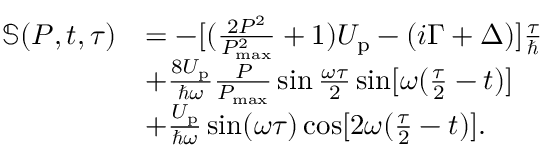<formula> <loc_0><loc_0><loc_500><loc_500>\begin{array} { r l } { \mathbb { S } ( P , t , \tau ) } & { = - [ ( \frac { 2 P ^ { 2 } } { P _ { \max } ^ { 2 } } + 1 ) U _ { p } - ( i \Gamma + \Delta ) ] \frac { \tau } { } } \\ & { + \frac { 8 U _ { p } } { \hbar { \omega } } \frac { P } { P _ { \max } } \sin \frac { \omega \tau } { 2 } \sin [ \omega ( \frac { \tau } { 2 } - t ) ] } \\ & { + \frac { U _ { p } } { \hbar { \omega } } \sin ( \omega \tau ) \cos [ 2 \omega ( \frac { \tau } { 2 } - t ) ] . } \end{array}</formula> 